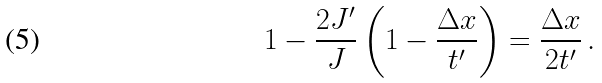Convert formula to latex. <formula><loc_0><loc_0><loc_500><loc_500>1 - \frac { 2 J ^ { \prime } } { J } \left ( 1 - \frac { \Delta x } { t ^ { \prime } } \right ) = \frac { \Delta x } { 2 t ^ { \prime } } \, .</formula> 